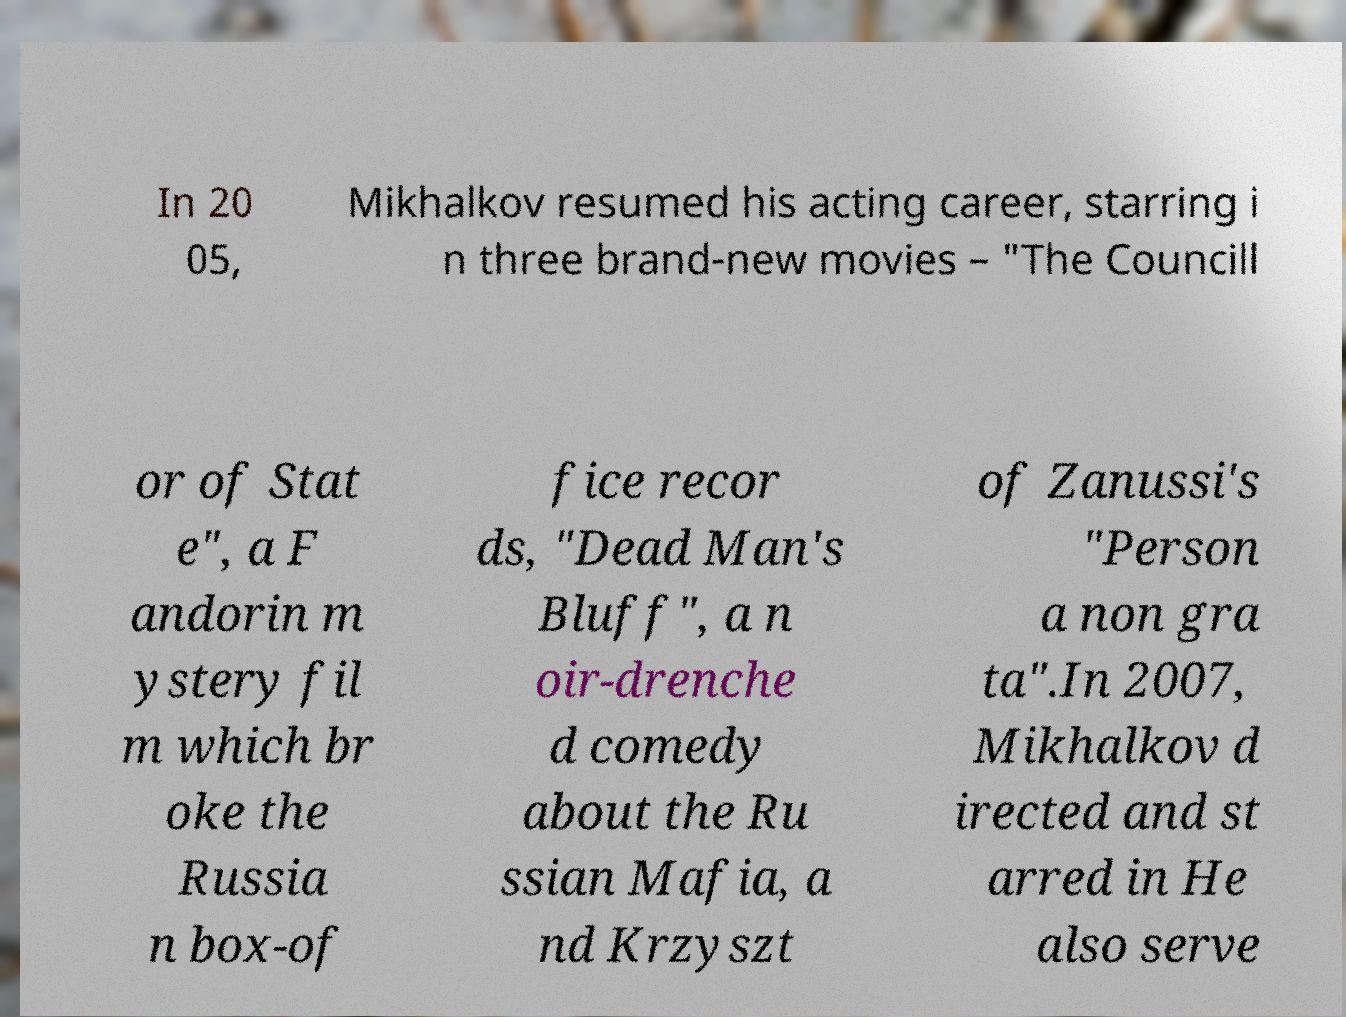Can you accurately transcribe the text from the provided image for me? In 20 05, Mikhalkov resumed his acting career, starring i n three brand-new movies – "The Councill or of Stat e", a F andorin m ystery fil m which br oke the Russia n box-of fice recor ds, "Dead Man's Bluff", a n oir-drenche d comedy about the Ru ssian Mafia, a nd Krzyszt of Zanussi's "Person a non gra ta".In 2007, Mikhalkov d irected and st arred in He also serve 